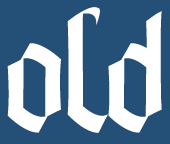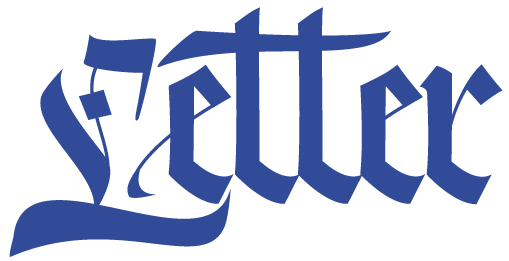What words can you see in these images in sequence, separated by a semicolon? old; Letter 